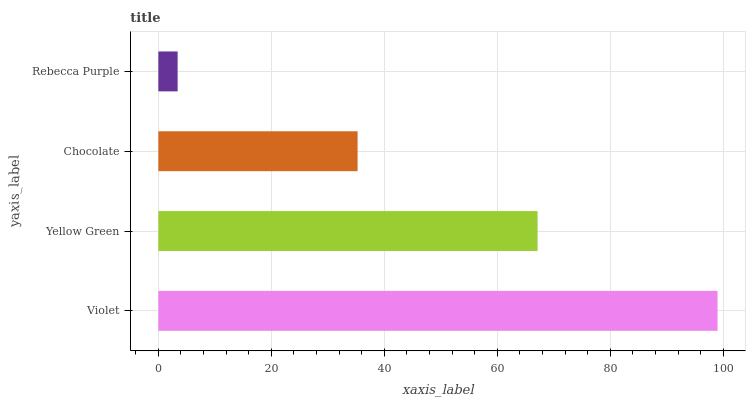Is Rebecca Purple the minimum?
Answer yes or no. Yes. Is Violet the maximum?
Answer yes or no. Yes. Is Yellow Green the minimum?
Answer yes or no. No. Is Yellow Green the maximum?
Answer yes or no. No. Is Violet greater than Yellow Green?
Answer yes or no. Yes. Is Yellow Green less than Violet?
Answer yes or no. Yes. Is Yellow Green greater than Violet?
Answer yes or no. No. Is Violet less than Yellow Green?
Answer yes or no. No. Is Yellow Green the high median?
Answer yes or no. Yes. Is Chocolate the low median?
Answer yes or no. Yes. Is Rebecca Purple the high median?
Answer yes or no. No. Is Violet the low median?
Answer yes or no. No. 